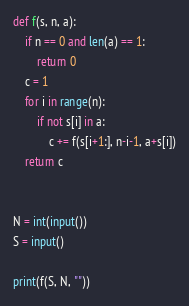Convert code to text. <code><loc_0><loc_0><loc_500><loc_500><_Python_>def f(s, n, a):
    if n == 0 and len(a) == 1:
        return 0
    c = 1
    for i in range(n):
        if not s[i] in a:
            c += f(s[i+1:], n-i-1, a+s[i])
    return c


N = int(input())
S = input()

print(f(S, N, ""))
</code> 